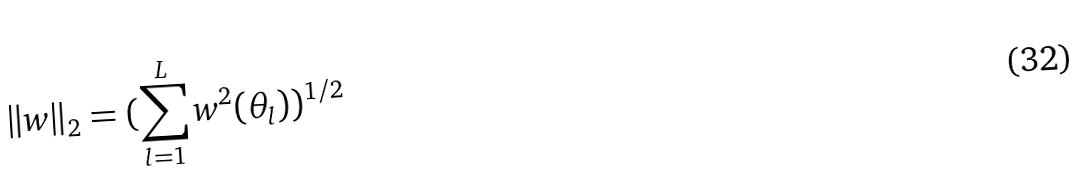<formula> <loc_0><loc_0><loc_500><loc_500>\| w \| _ { 2 } = ( \sum _ { l = 1 } ^ { L } w ^ { 2 } ( \theta _ { l } ) ) ^ { 1 / 2 }</formula> 